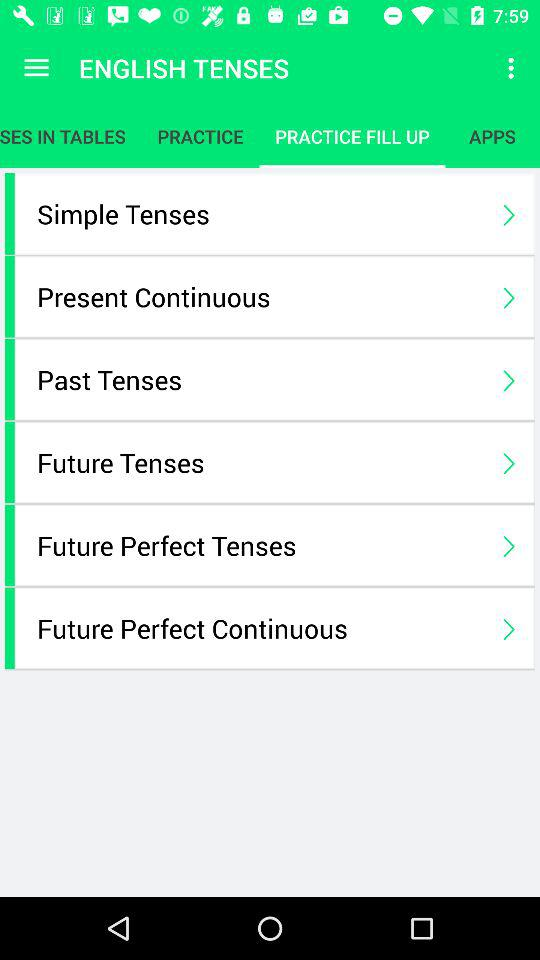What is the selected tab of English tenses? The selected tab is "PRACTICE FILL UP". 